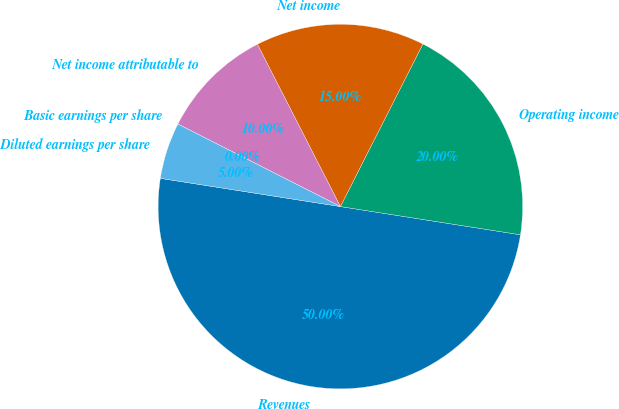Convert chart. <chart><loc_0><loc_0><loc_500><loc_500><pie_chart><fcel>Revenues<fcel>Operating income<fcel>Net income<fcel>Net income attributable to<fcel>Basic earnings per share<fcel>Diluted earnings per share<nl><fcel>50.0%<fcel>20.0%<fcel>15.0%<fcel>10.0%<fcel>0.0%<fcel>5.0%<nl></chart> 